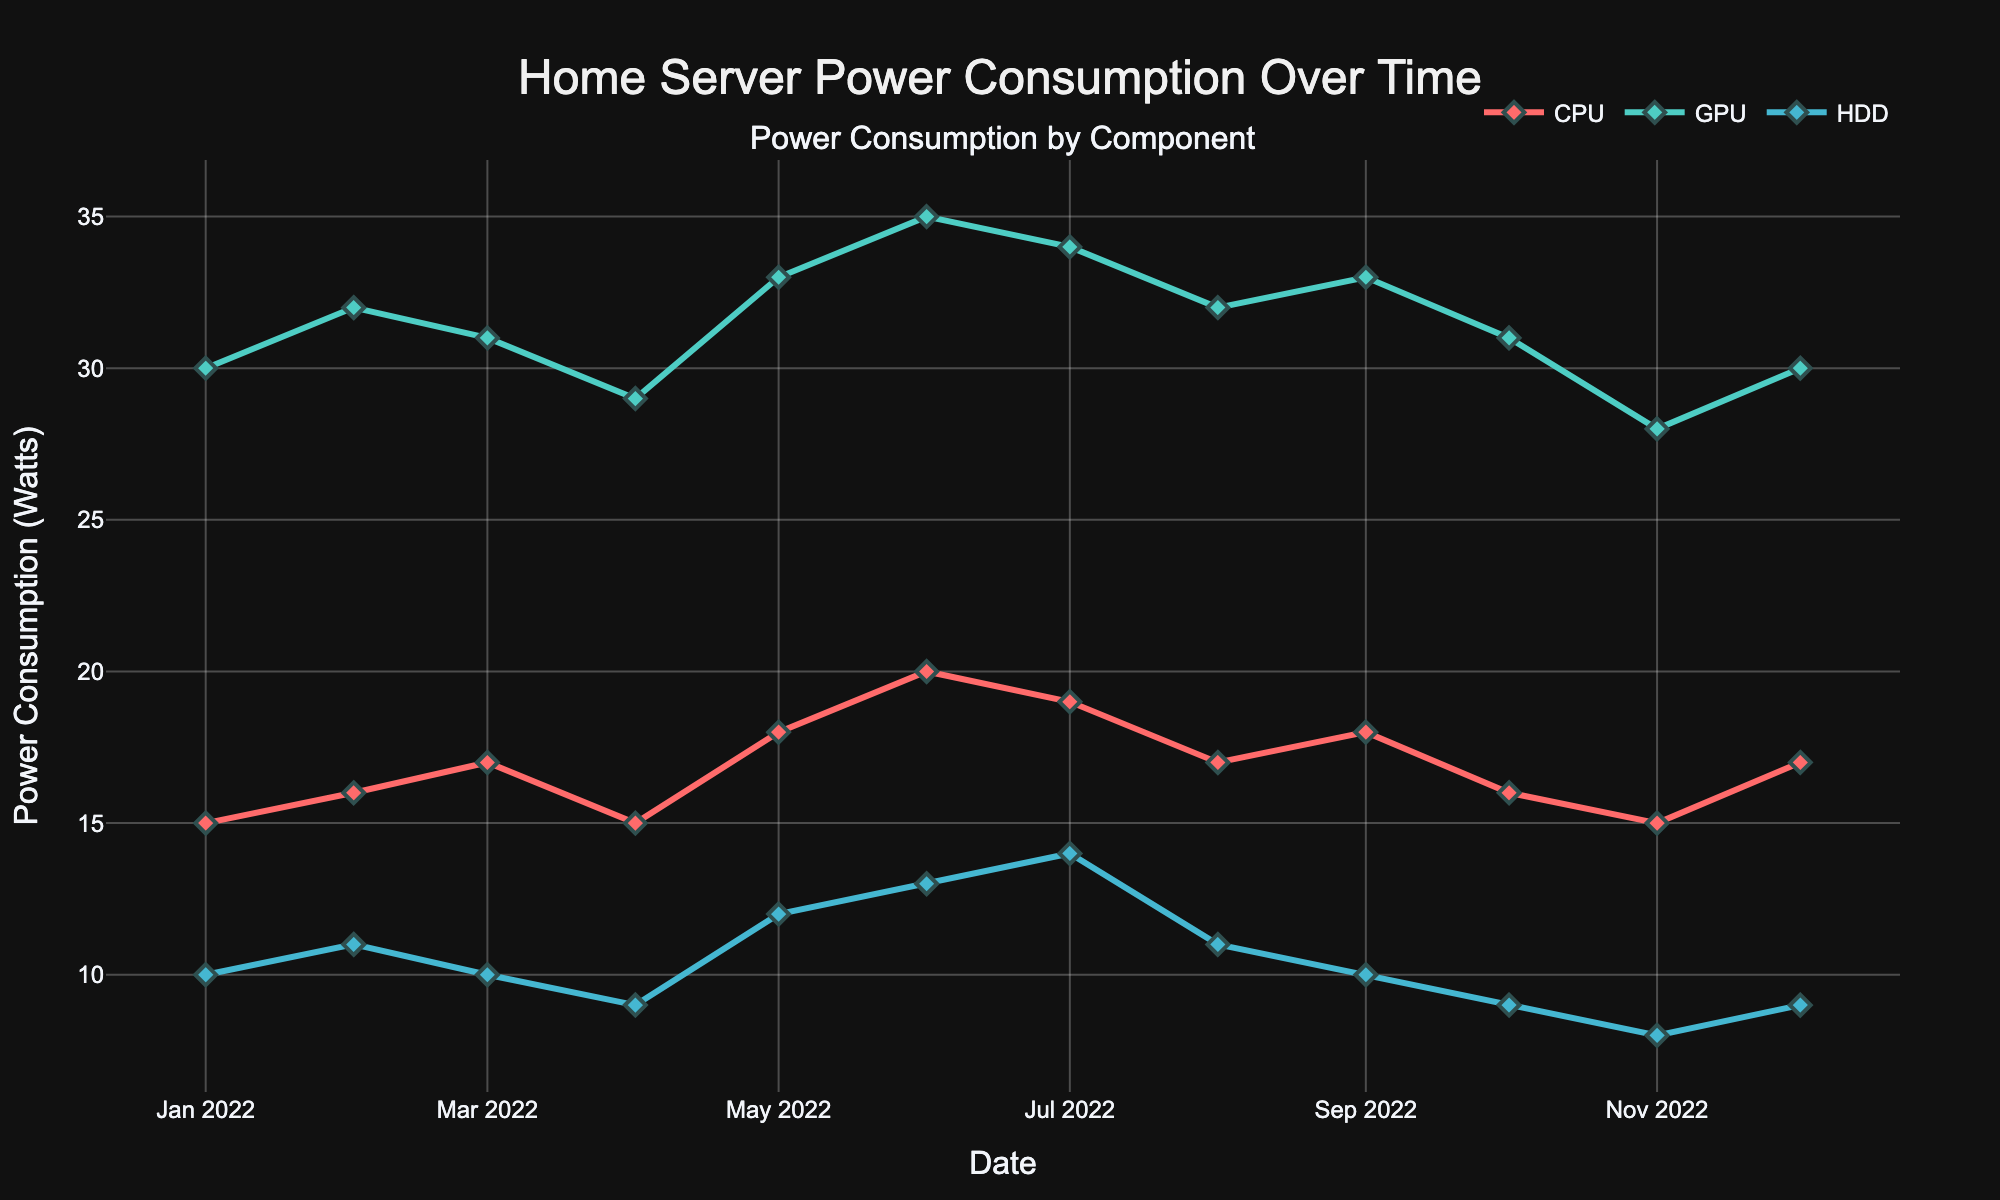what is the total power consumption of the GPU on April 1, 2022? The figure shows that the power consumption of the GPU on April 1, 2022, is 29 Watts.
Answer: 29 Watts Which component has the highest power consumption on June 1, 2022? On June 1, 2022, the figure shows three components' power consumptions: CPU with 20 Watts, GPU with 35 Watts, and HDD with 13 Watts. The GPU has the highest power consumption at 35 Watts.
Answer: GPU What is the average power consumption of the CPU over the entire year? The power consumption values for the CPU over each month are: 15, 16, 17, 15, 18, 20, 19, 17, 18, 16, 15, 17. Adding these gives 203. There are 12 months, so 203 / 12 = 16.92.
Answer: 16.92 Watts How did the power consumption of the HDD change from February 1, 2022, to March 1, 2022? In the figure, the HDD's power consumption on February 1, 2022, is 11 Watts and on March 1, 2022, is 10 Watts. The power consumption decreased by 1 Watt.
Answer: Decreased by 1 Watt During which month did the GPU show a sudden drop in power consumption, and by how many Watts? The figure shows a sudden drop in GPU's power consumption from October 1, 2022 (31 Watts) to November 1, 2022 (28 Watts), making a decrease of 3 Watts.
Answer: November, 3 Watts What is the combined power consumption of all components on December 1, 2022? The combined power consumption on December 1, 2022, is the sum of the CPU (17 Watts), GPU (30 Watts), and HDD (9 Watts), which is 17 + 30 + 9 = 56 Watts.
Answer: 56 Watts Compare the power consumption trends of the CPU and GPU across the year. Which one showed more variability? The figure shows that the GPU's power consumption ranged from 28 to 35 Watts, while the CPU's ranged from 15 to 20 Watts. The GPU has a wider range of variability (7 Watts) compared to the CPU (5 Watts).
Answer: GPU What is the highest power consumption recorded for the HDD within the year? The highest power consumption for the HDD is shown to be 14 Watts, recorded in July 2022.
Answer: 14 Watts 